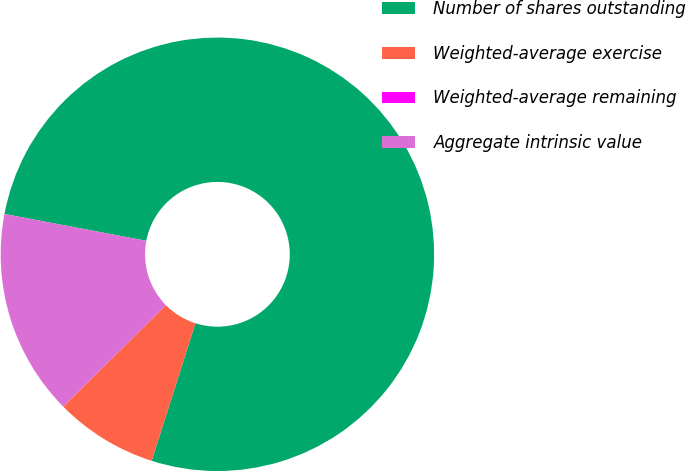<chart> <loc_0><loc_0><loc_500><loc_500><pie_chart><fcel>Number of shares outstanding<fcel>Weighted-average exercise<fcel>Weighted-average remaining<fcel>Aggregate intrinsic value<nl><fcel>76.92%<fcel>7.69%<fcel>0.0%<fcel>15.38%<nl></chart> 